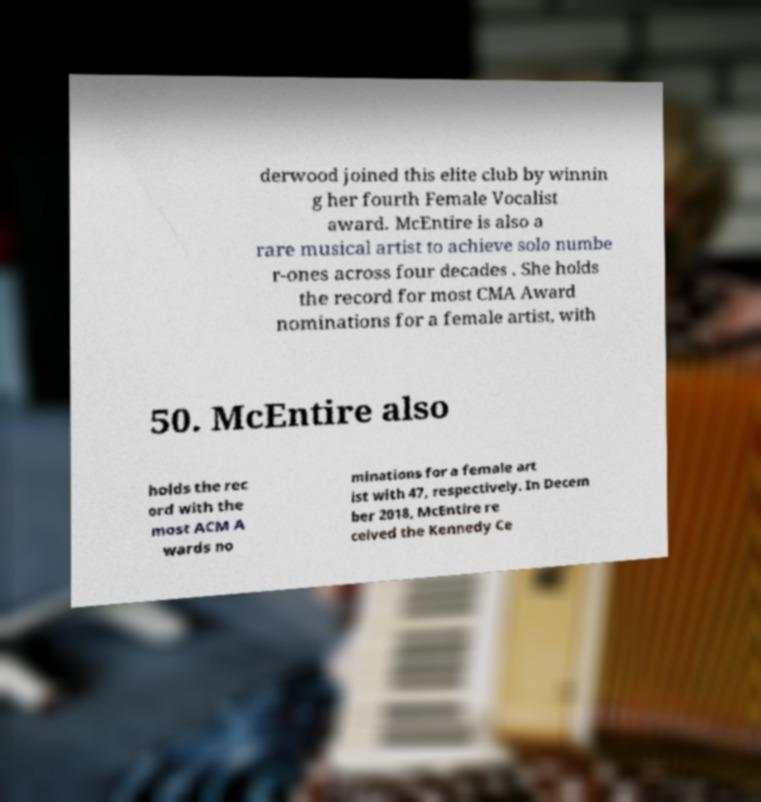Could you extract and type out the text from this image? derwood joined this elite club by winnin g her fourth Female Vocalist award. McEntire is also a rare musical artist to achieve solo numbe r-ones across four decades . She holds the record for most CMA Award nominations for a female artist, with 50. McEntire also holds the rec ord with the most ACM A wards no minations for a female art ist with 47, respectively. In Decem ber 2018, McEntire re ceived the Kennedy Ce 